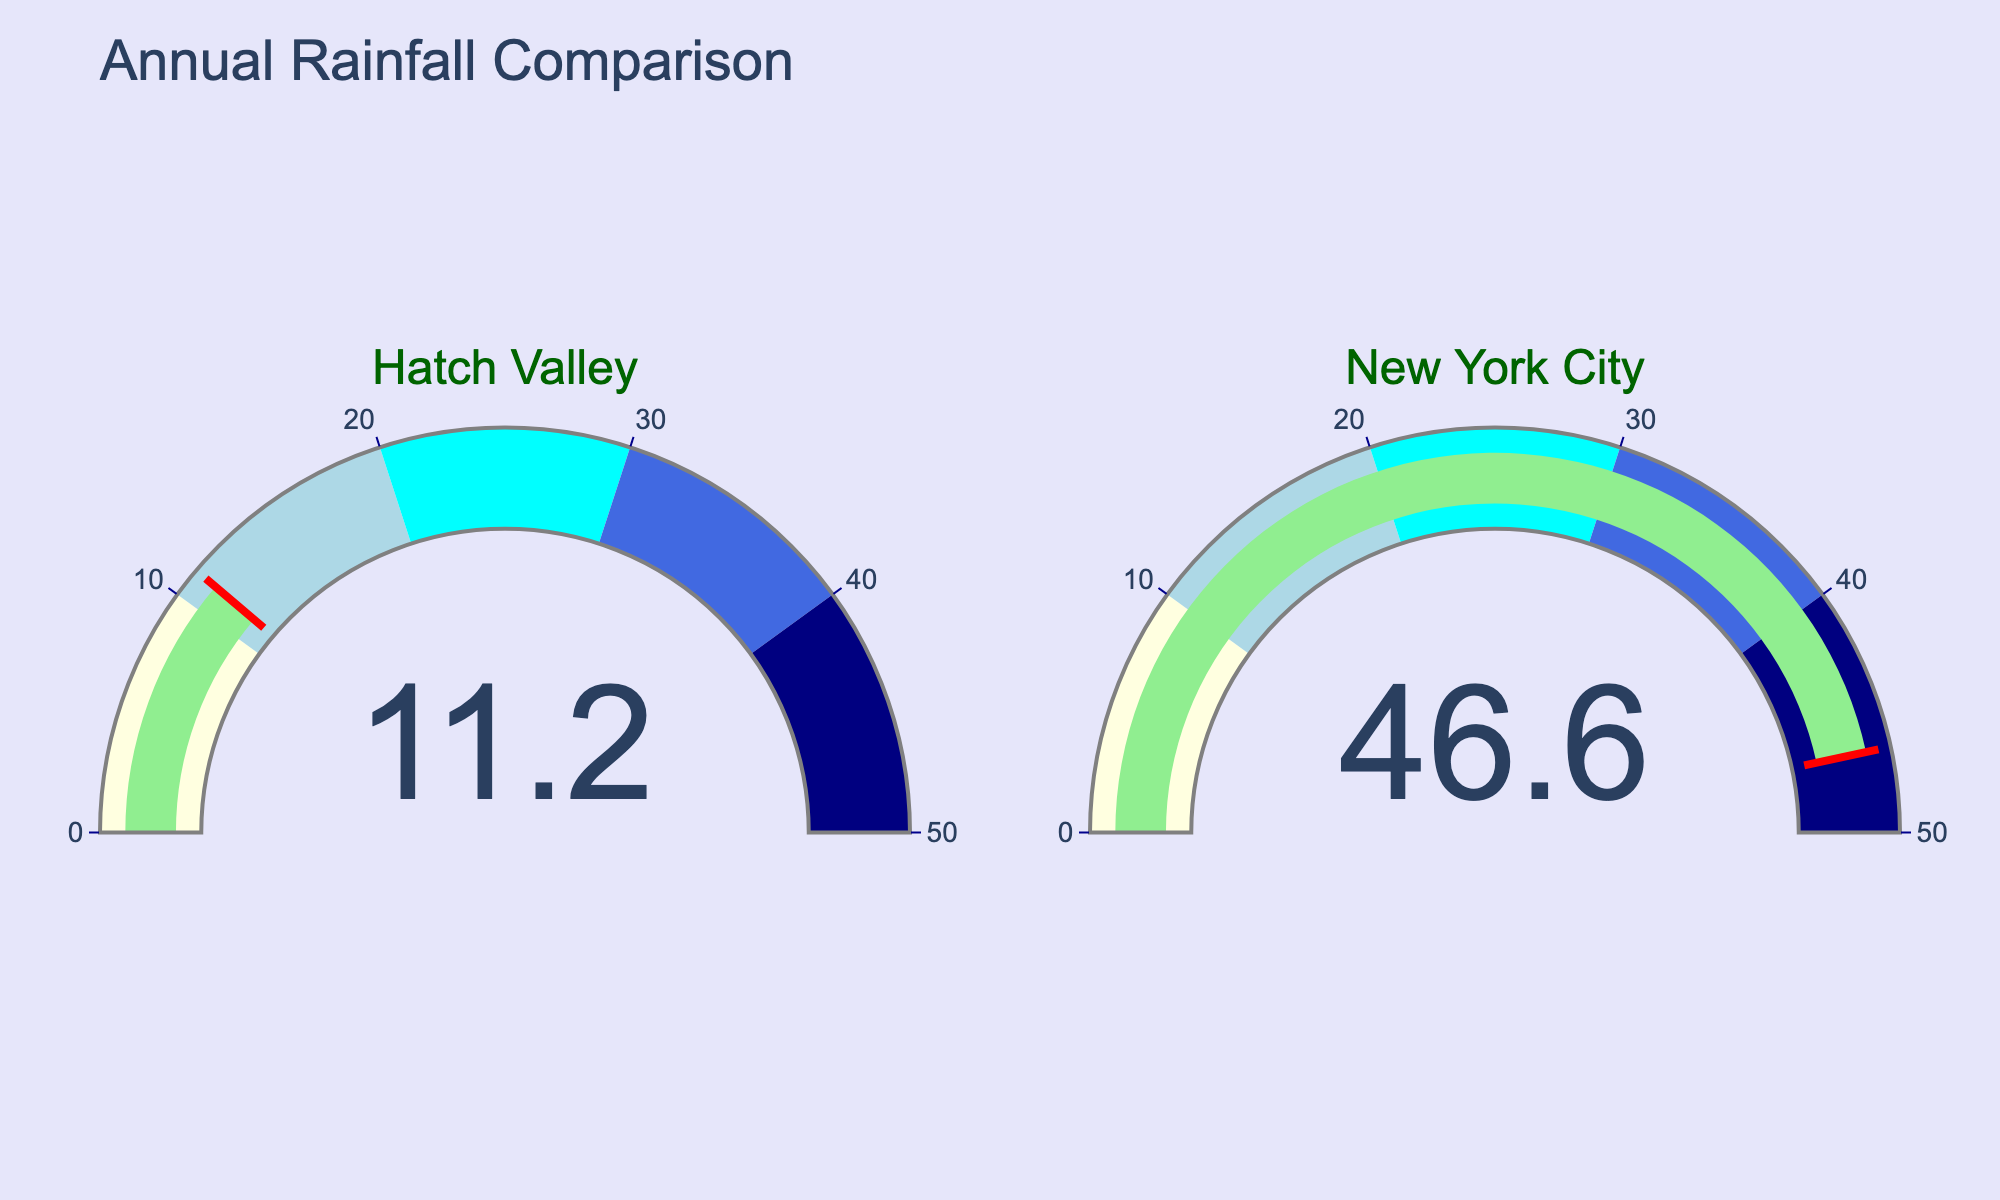What's the title of the figure? The title is mentioned at the top center of the figure indicating the main topic of the data comparison.
Answer: Annual Rainfall Comparison What is the annual rainfall in Hatch Valley? The gauge labeled "Hatch Valley" indicates the annual rainfall value.
Answer: 11.2 inches What is the annual rainfall in New York City? The gauge labeled "New York City" indicates the annual rainfall value.
Answer: 46.6 inches Which location has a higher annual rainfall? By comparing the values shown on both gauges, New York City has a value of 46.6 inches, whereas Hatch Valley has 11.2 inches.
Answer: New York City How much more annual rainfall does New York City receive compared to Hatch Valley? Subtract the annual rainfall of Hatch Valley (11.2 inches) from that of New York City (46.6 inches) to find the difference.
Answer: 35.4 inches What color is the bar on the gauge? The bar on each gauge is a specific color indicating the rainfall value.
Answer: Light green Between what value ranges does the color 'light blue' appear on the gauges? The gauge steps show different colors for different ranges: light blue is one of these colors.
Answer: 10 to 20 inches What is the maximum value shown on the gauge axis? Both gauges have their axis range mentioned with upper and lower limits.
Answer: 50 inches Which color indicates the highest range in the gauge? The gauge colors change with different value ranges, and the highest range is distinctly colored.
Answer: Navy Does the annual rainfall in Hatch Valley fall within the 'light yellow' range? Comparing the value of 11.2 inches with the step ranges, light yellow covers 0 to 10 inches.
Answer: No 